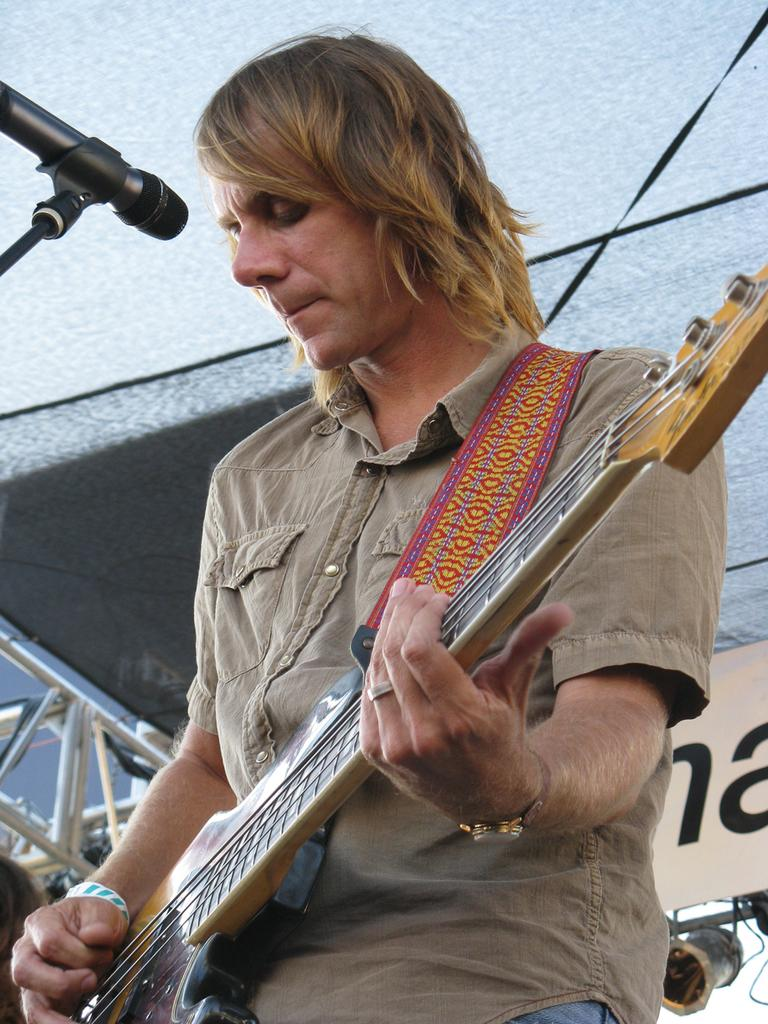What is the man in the image doing? The man is playing a guitar in the image. How is the man playing the guitar? The man is using his hand to play the guitar. What is in front of the man? There is a microphone in front of the man. What can be seen in the background of the image? There are steel rods, a light, and a wall visible in the background. What type of son does the man have, and how does he communicate with him in the image? There is no information about the man having a son or any form of communication in the image. 